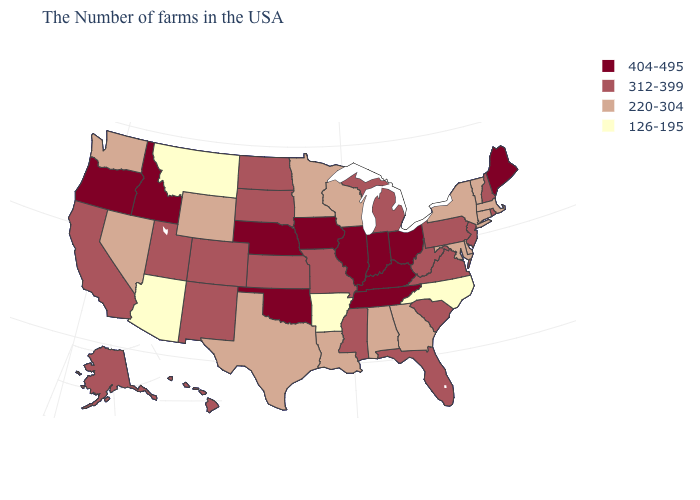What is the lowest value in the MidWest?
Quick response, please. 220-304. How many symbols are there in the legend?
Quick response, please. 4. Does the first symbol in the legend represent the smallest category?
Write a very short answer. No. Among the states that border Minnesota , which have the highest value?
Write a very short answer. Iowa. What is the value of Iowa?
Be succinct. 404-495. Name the states that have a value in the range 404-495?
Short answer required. Maine, Ohio, Kentucky, Indiana, Tennessee, Illinois, Iowa, Nebraska, Oklahoma, Idaho, Oregon. How many symbols are there in the legend?
Keep it brief. 4. Does Kentucky have the highest value in the South?
Keep it brief. Yes. Name the states that have a value in the range 126-195?
Give a very brief answer. North Carolina, Arkansas, Montana, Arizona. Name the states that have a value in the range 220-304?
Be succinct. Massachusetts, Vermont, Connecticut, New York, Delaware, Maryland, Georgia, Alabama, Wisconsin, Louisiana, Minnesota, Texas, Wyoming, Nevada, Washington. Does the first symbol in the legend represent the smallest category?
Give a very brief answer. No. What is the value of Montana?
Keep it brief. 126-195. What is the value of Massachusetts?
Short answer required. 220-304. Which states have the lowest value in the USA?
Short answer required. North Carolina, Arkansas, Montana, Arizona. Which states have the highest value in the USA?
Be succinct. Maine, Ohio, Kentucky, Indiana, Tennessee, Illinois, Iowa, Nebraska, Oklahoma, Idaho, Oregon. 